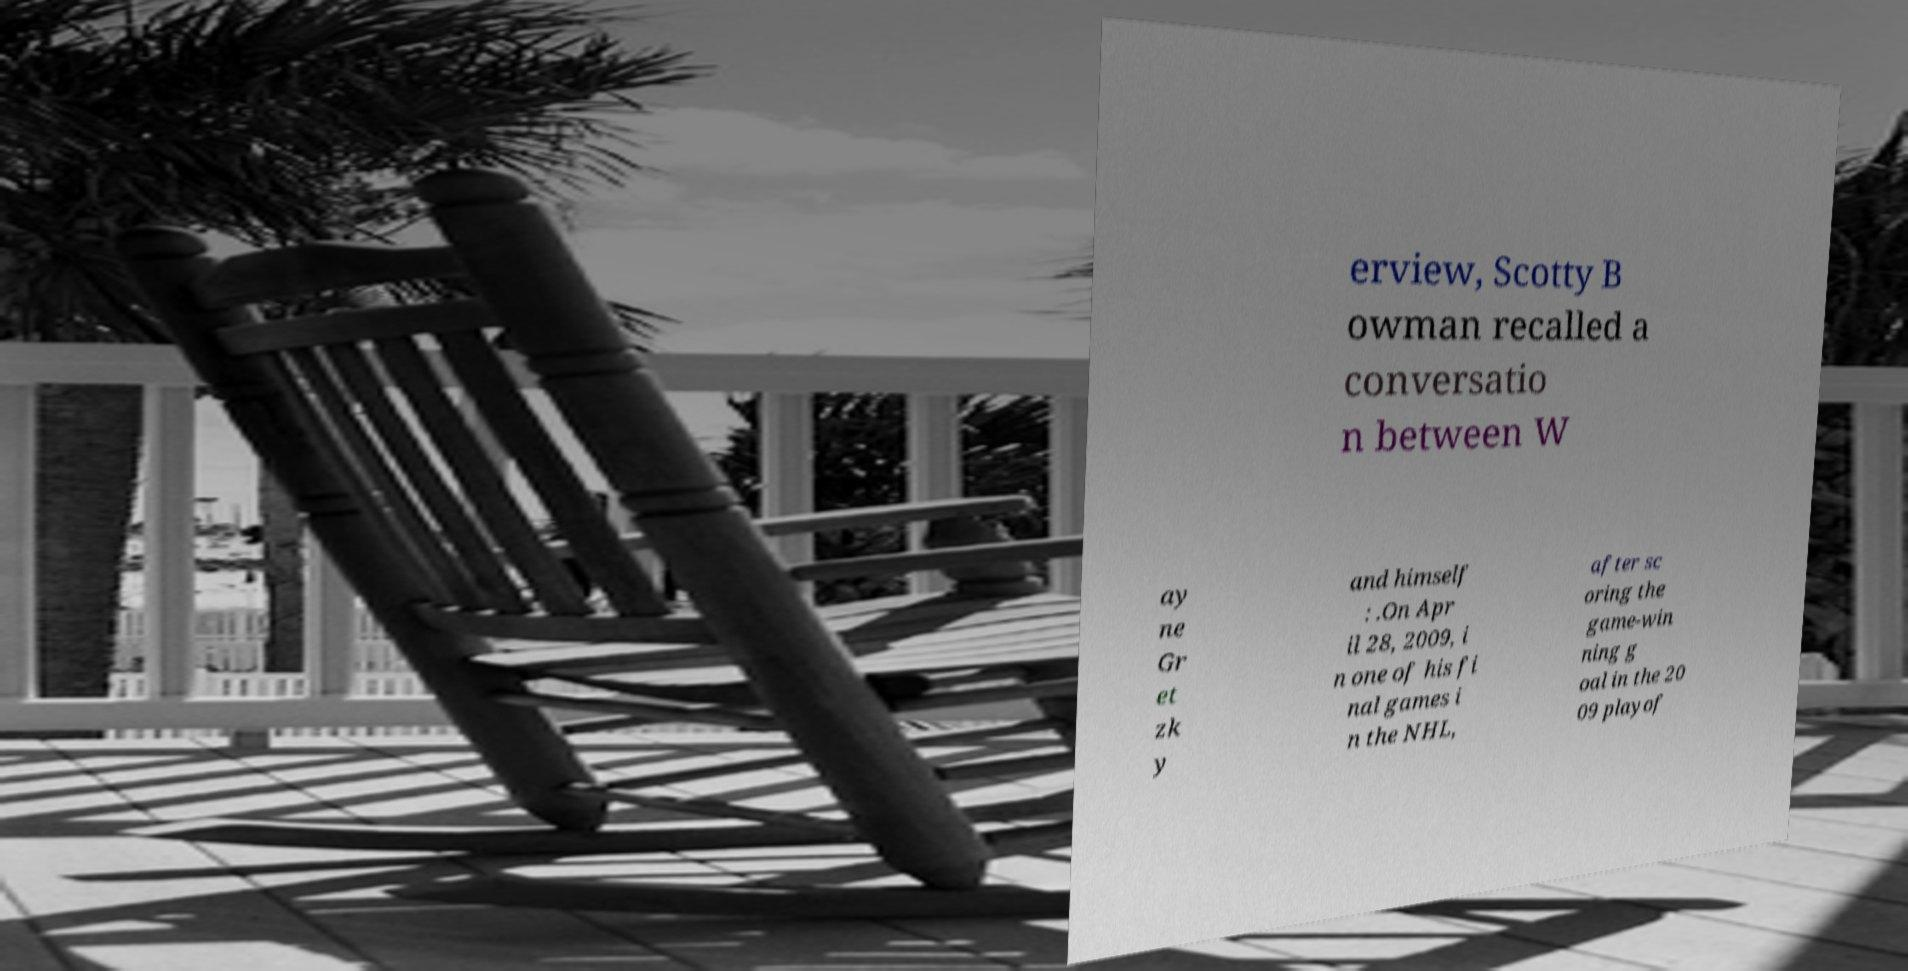Could you extract and type out the text from this image? erview, Scotty B owman recalled a conversatio n between W ay ne Gr et zk y and himself : .On Apr il 28, 2009, i n one of his fi nal games i n the NHL, after sc oring the game-win ning g oal in the 20 09 playof 